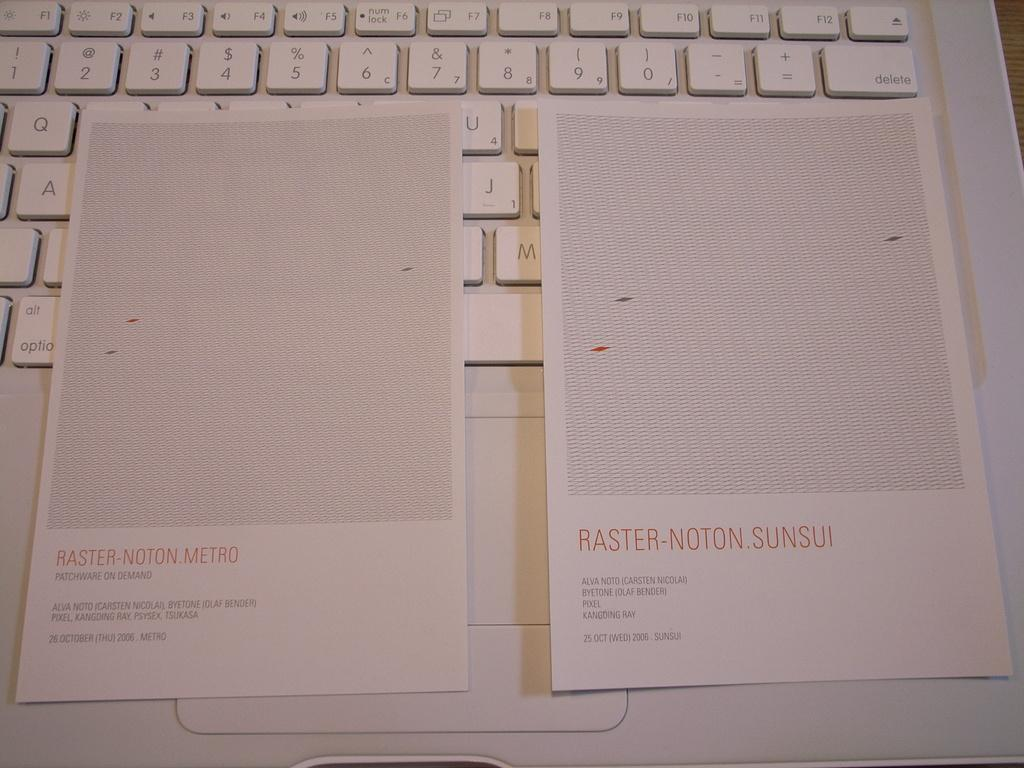<image>
Describe the image concisely. Pages that say Raster-Noton-Sunsui on them laying on top of a keyboard. 